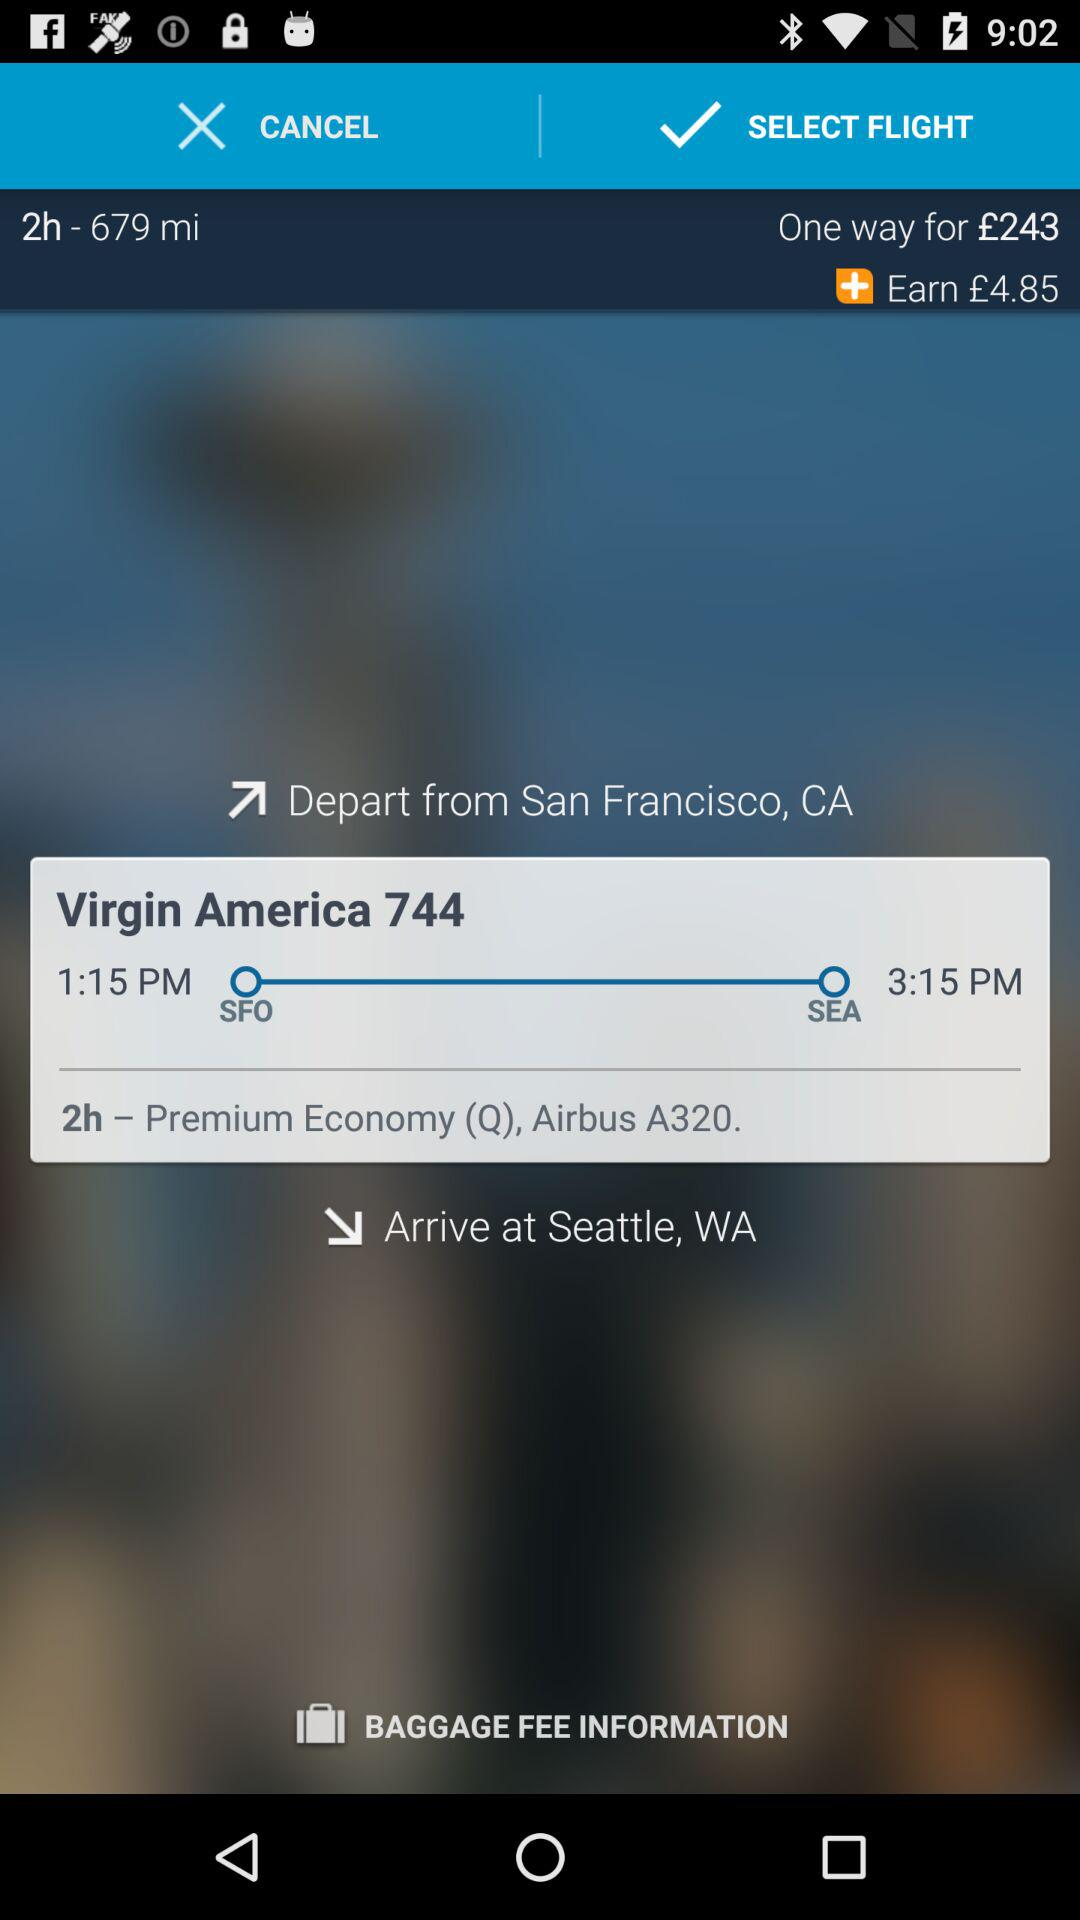What is the departure time of the flight? The departure time of the flight is 1:15 PM. 